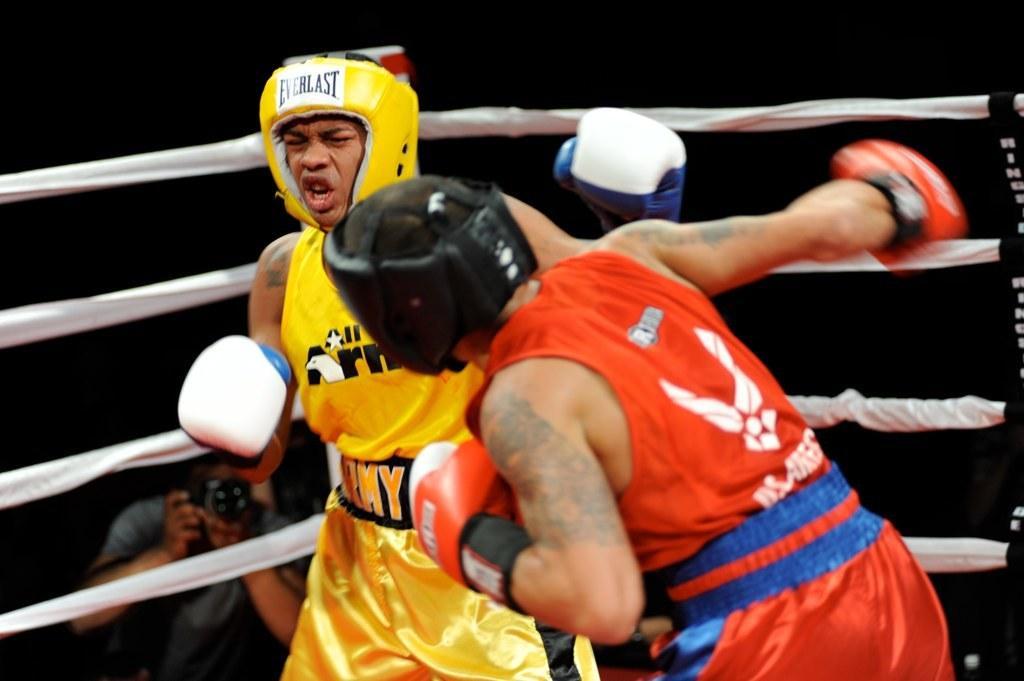How would you summarize this image in a sentence or two? There are two persons wearing red and yellow color dress are playing boxing sport and there is a person holding a camera in the left corner. 